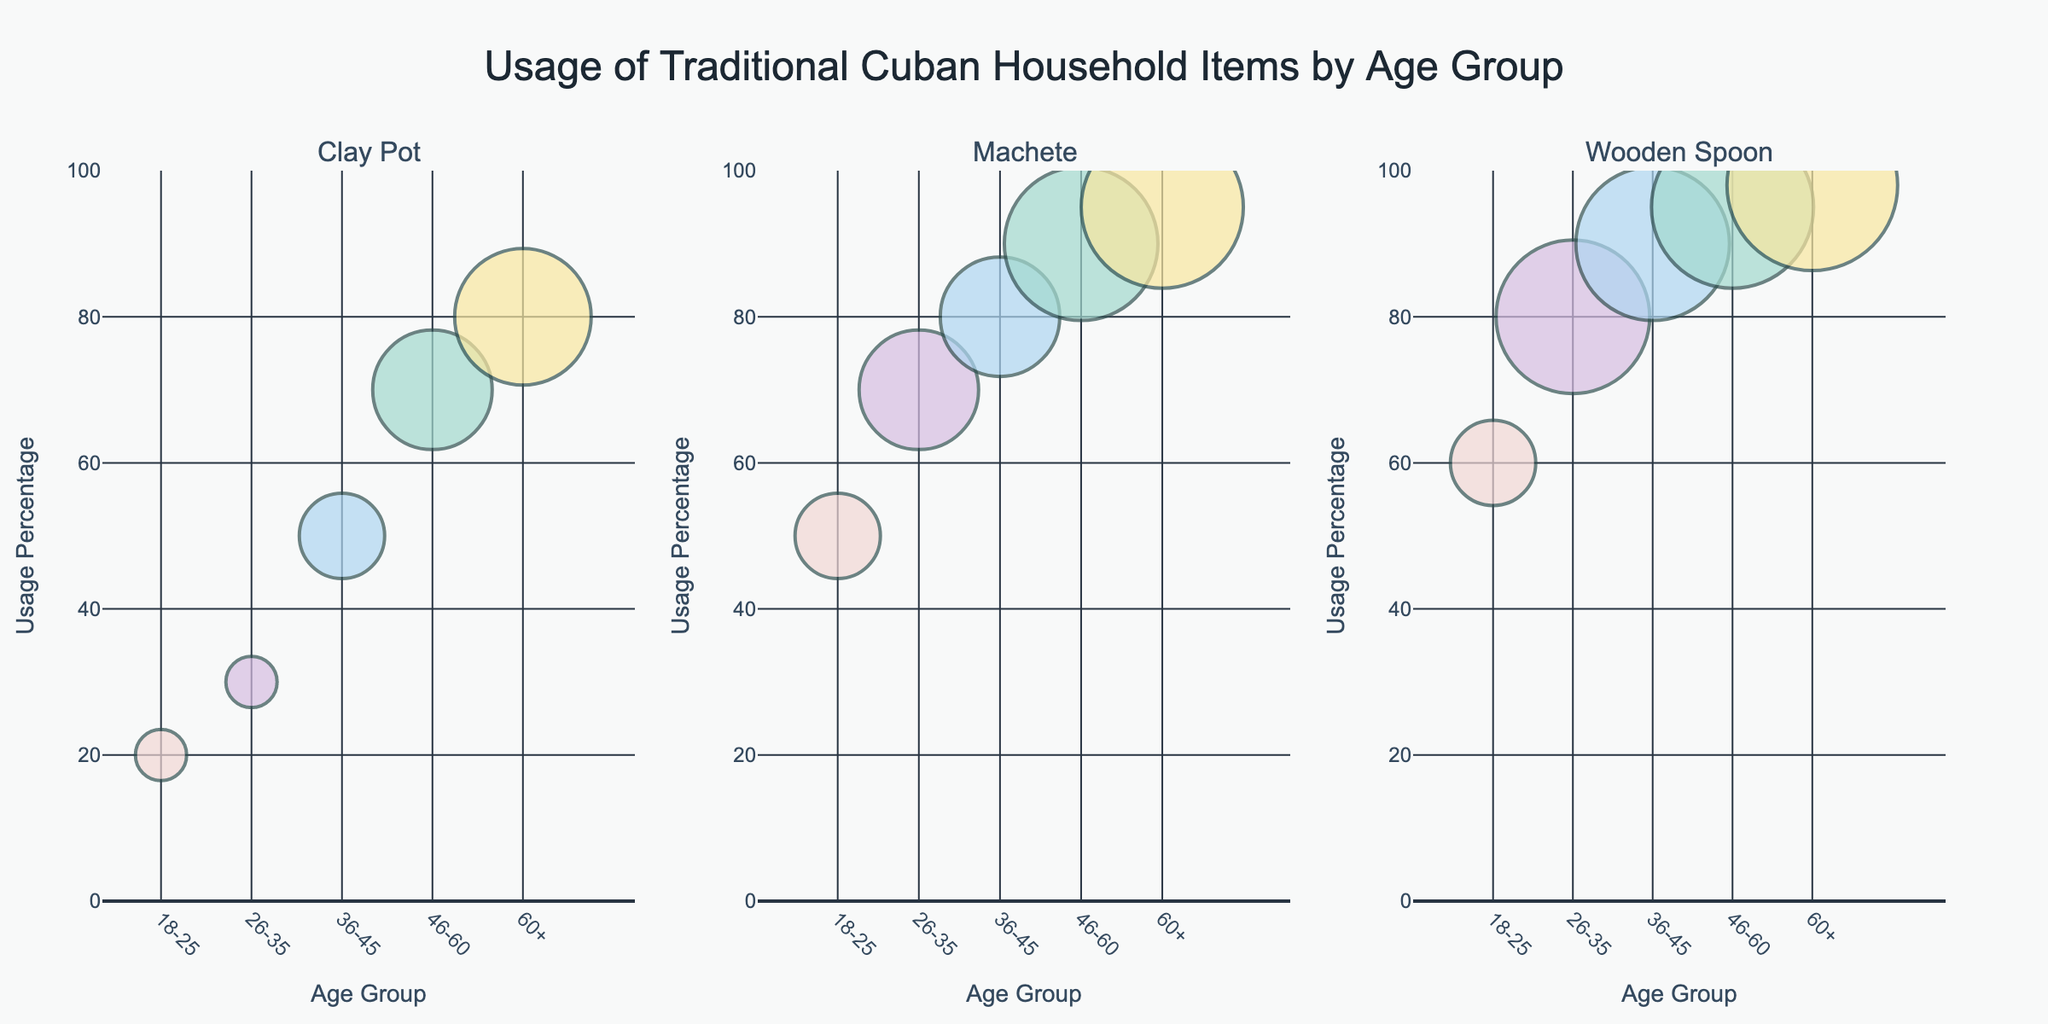What is the title of the figure? The title is displayed at the top center of the figure. It reads "Usage of Traditional Cuban Household Items by Age Group".
Answer: Usage of Traditional Cuban Household Items by Age Group Which age group uses the Wooden Spoon the most? The y-axis shows the usage percentage, and the Wooden Spoon panel shows bubbles for different age groups. The age group 60+ has the highest usage percentage of 98%.
Answer: 60+ How often do people aged 46-60 use the Machete? By looking at the Machete panel and hovering over the bubble for the age group 46-60, the frequency is shown as "Always".
Answer: Always What is the usage percentage of Clay Pots for age group 36-45? Refer to the Clay Pot panel and find the bubble corresponding to the age group 36-45. The y-axis value next to this bubble is 50%.
Answer: 50% Compare the usage percentage of the Machete between age groups 18-25 and 26-35. Check the Machete panel and look at the y-axis values for the bubbles corresponding to the age groups 18-25 and 26-35. They are 50% and 70% respectively.
Answer: Age group 26-35 has higher usage Which item has the largest bubble size for the age group 26-35? In all three panels, look for the largest bubble within the age group 26-35. The Wooden Spoon bubble is the largest.
Answer: Wooden Spoon What is the average usage percentage of the Wooden Spoon across all age groups? Look at the Wooden Spoon panel and add the usage percentages: 60, 80, 90, 95, 98. The sum is 423. The average is 423 / 5 = 84.6.
Answer: 84.6% For the age group 18-25, compare the usage percentage of Machete and Clay Pot. Refer to the panel for Machete and Clay Pot, and note the y-axis values for the age group 18-25. The values are 50% and 20% respectively.
Answer: Machete has higher usage Which item has the highest usage percentage for any age group? Scan all panels for the bubble with the highest y-axis value. The Wooden Spoon for age group 60+ has the highest usage percentage at 98%.
Answer: Wooden Spoon (age 60+) How does the usage frequency of the Clay Pot change with age? Check the Clay Pot panel for the different age groups and read the frequency listed in the hover text. It changes from Occasionally, Occasionally, Often, Always, to Always.
Answer: Increases with age 